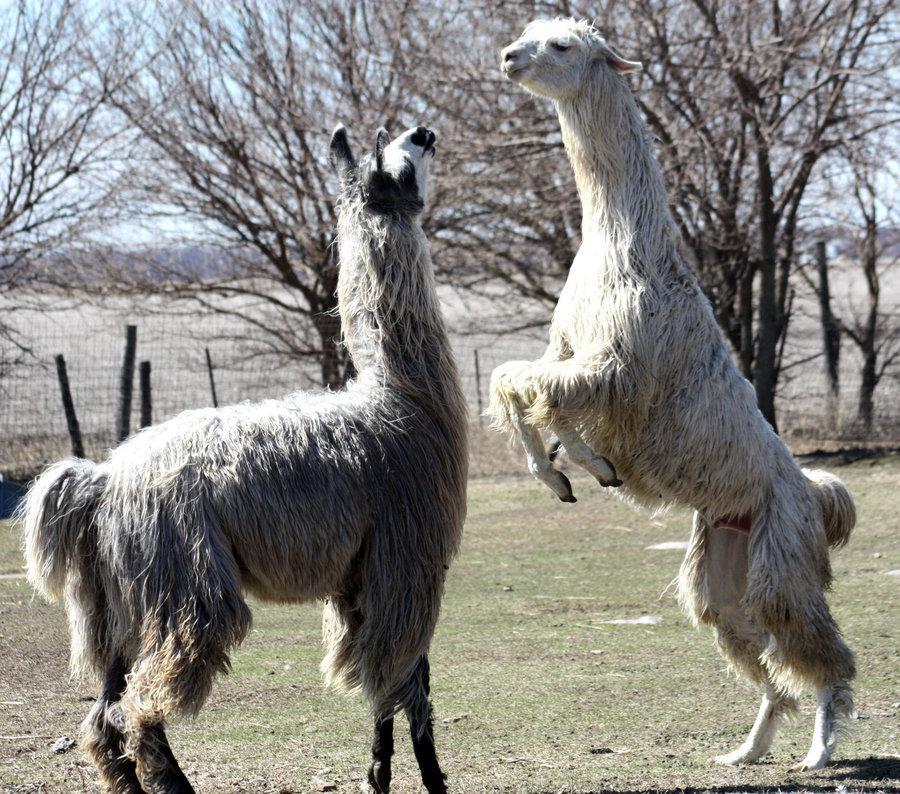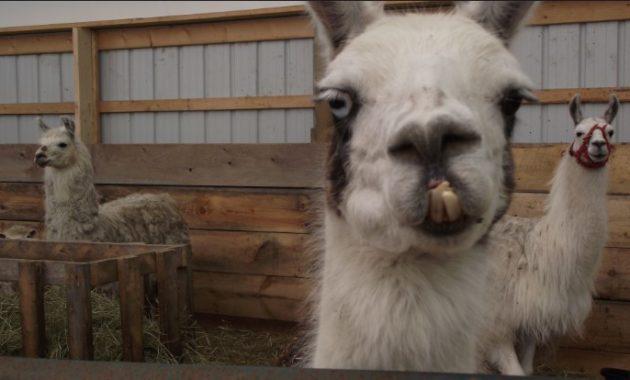The first image is the image on the left, the second image is the image on the right. Given the left and right images, does the statement "One image shows one dark-eyed white llama, which faces forward and has a partly open mouth revealing several yellow teeth." hold true? Answer yes or no. No. The first image is the image on the left, the second image is the image on the right. For the images displayed, is the sentence "There are two llamas in total." factually correct? Answer yes or no. No. 